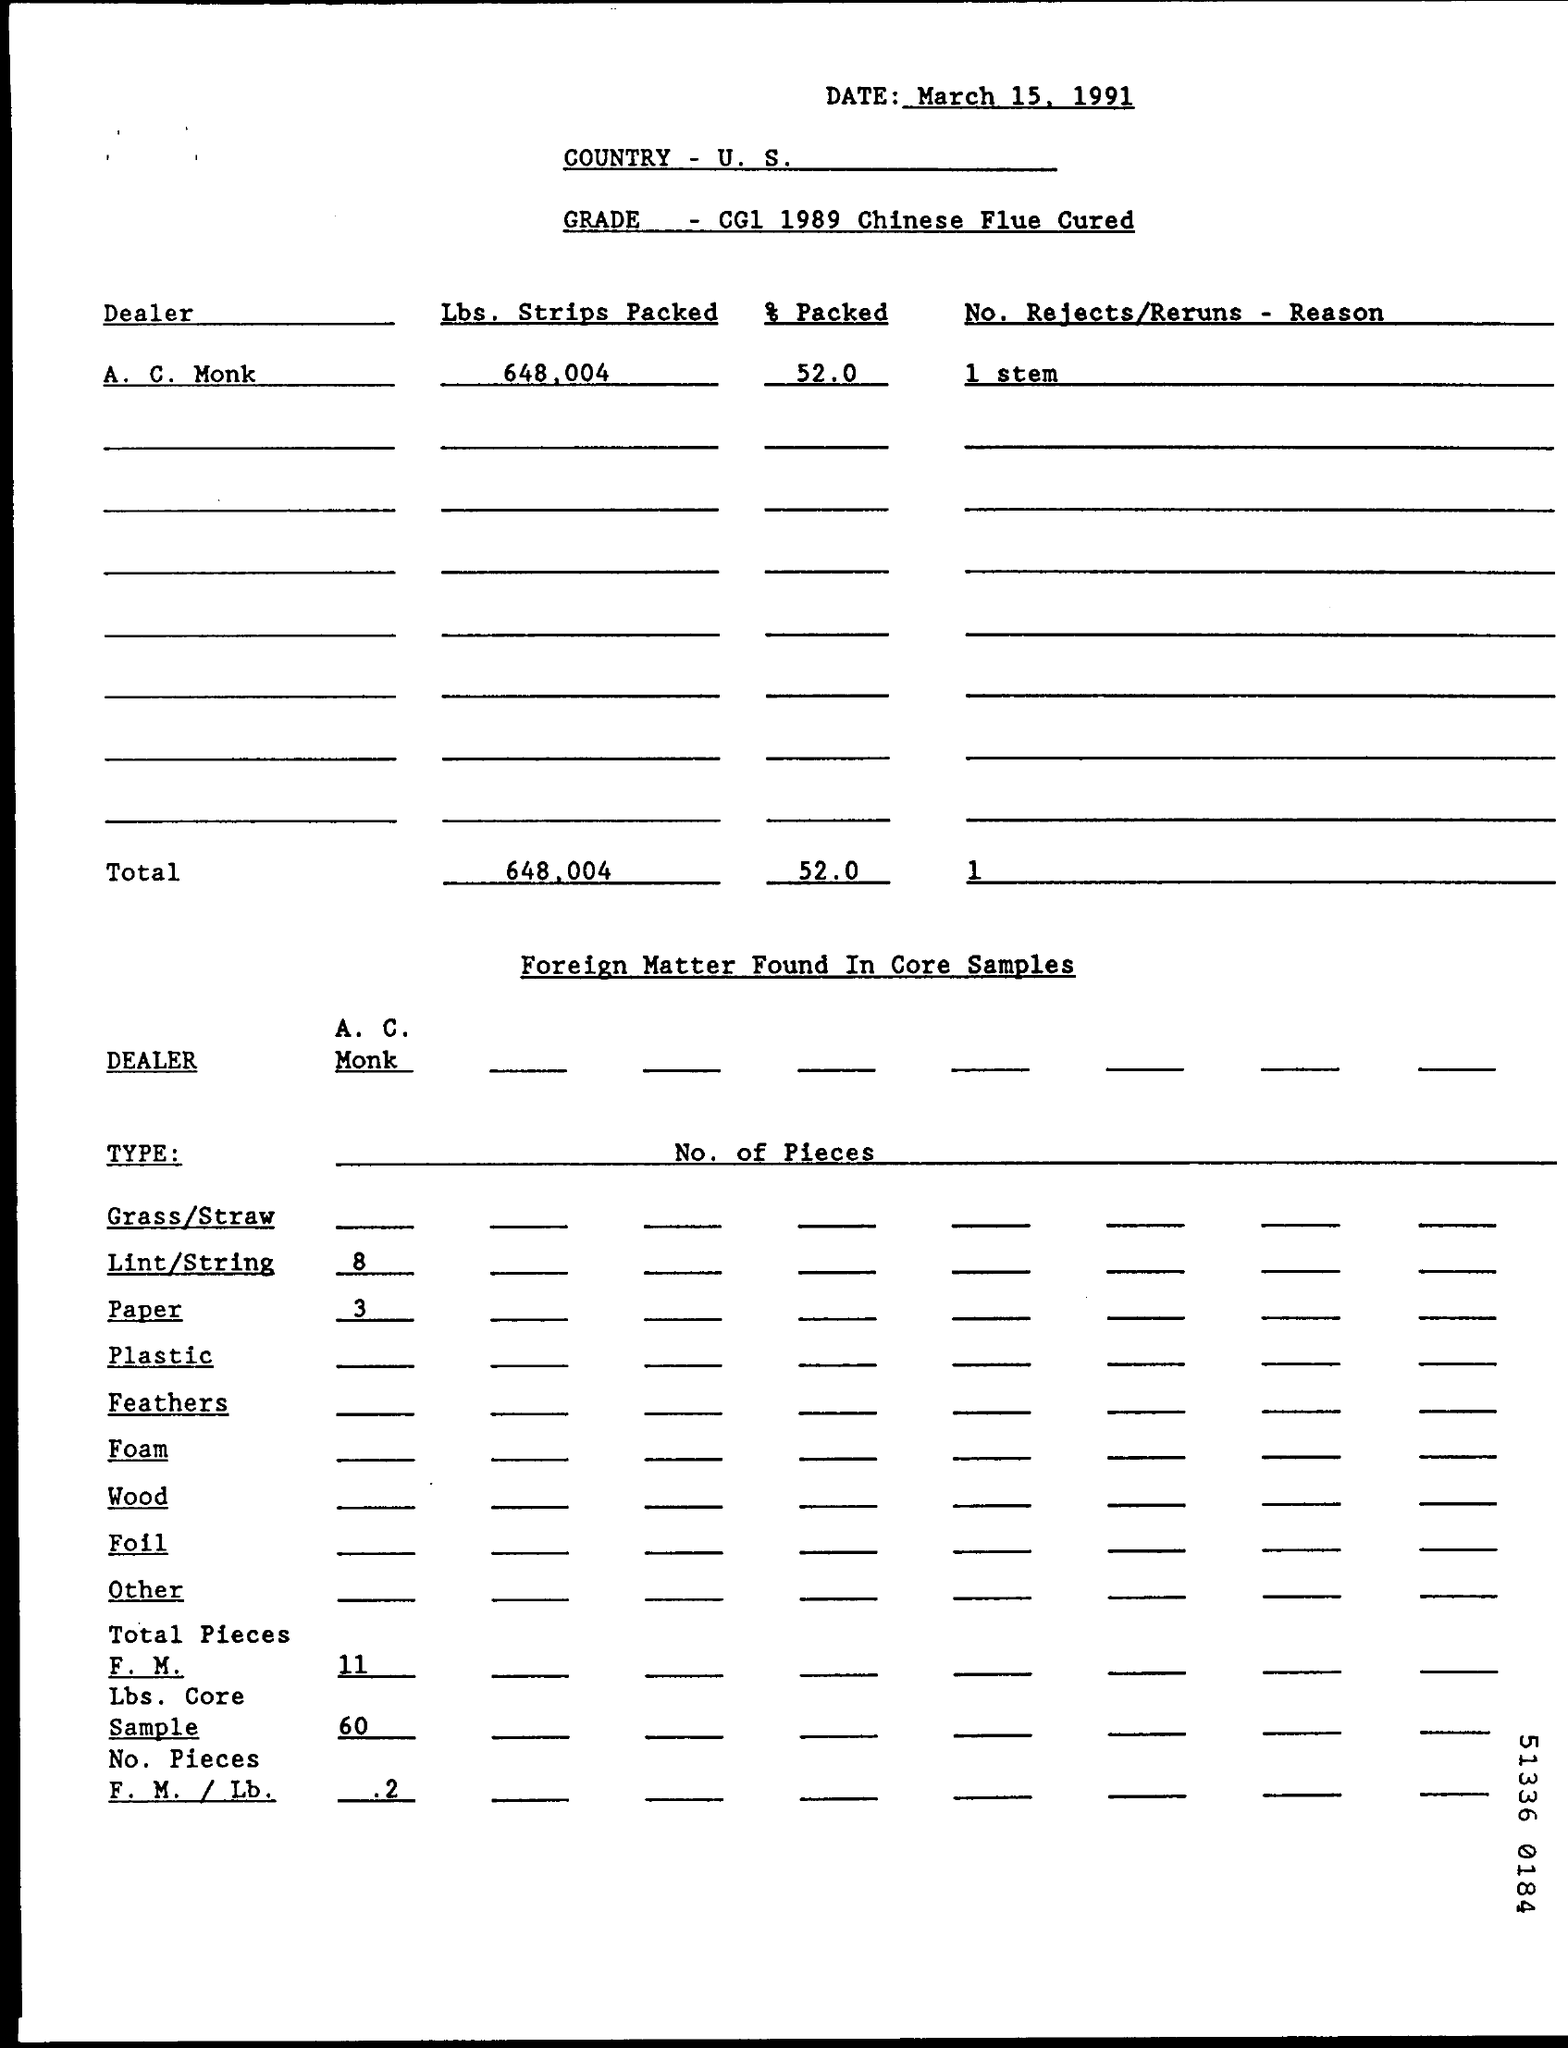Give some essential details in this illustration. This is a grade specification for Chinese Flue Cured tobacco from 1989. According to the information provided, 52.0% of the packing was done by A. C. Monk. The number of pieces of lint and strings found is 8. The document is dated March 15, 1991. 